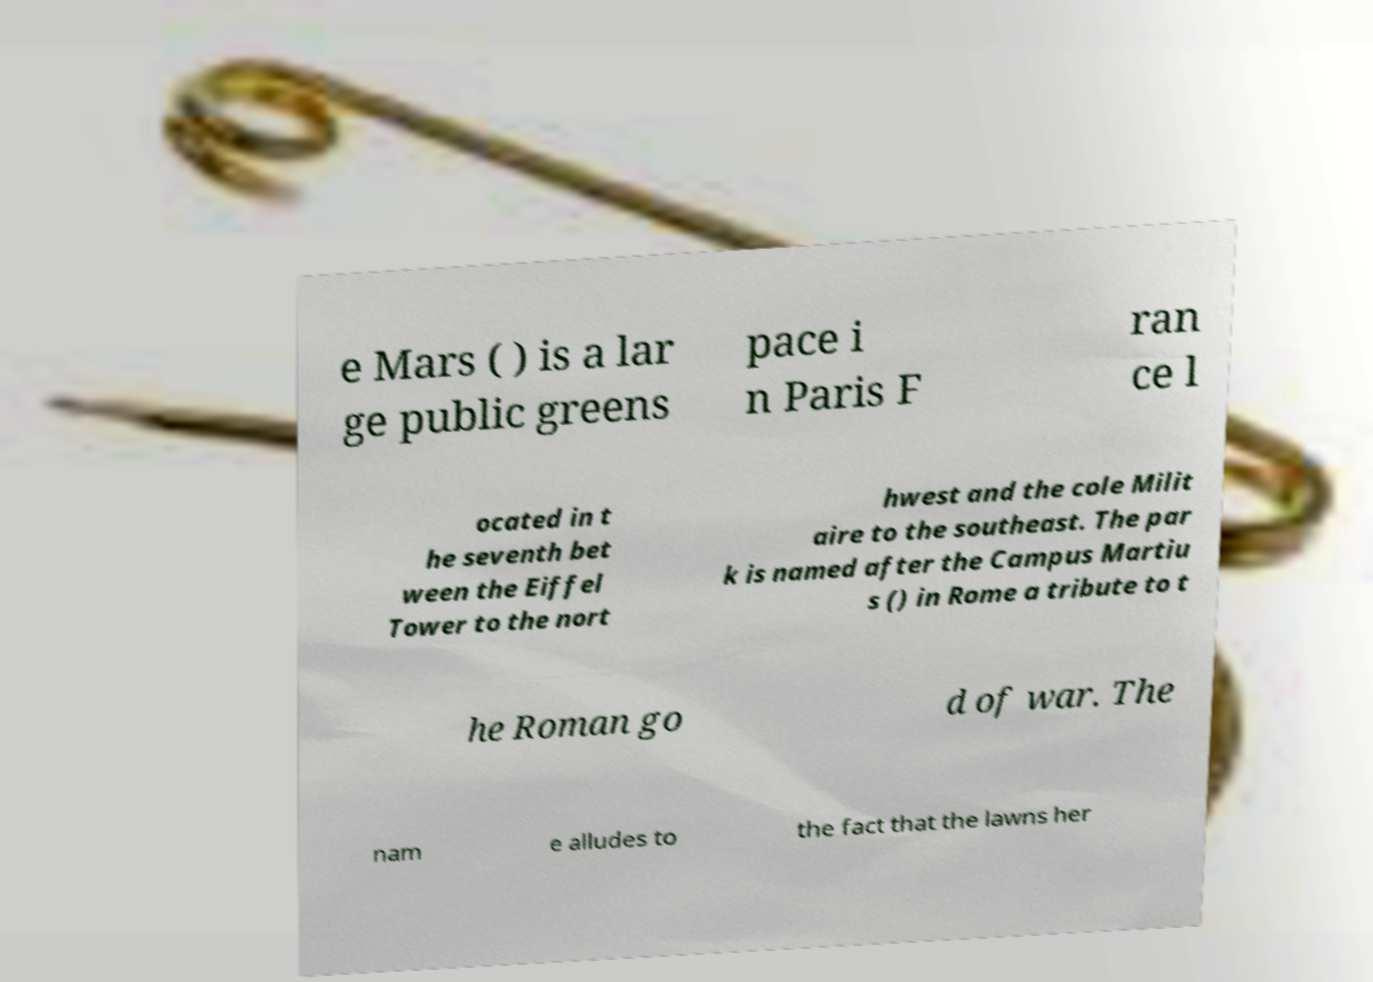Can you read and provide the text displayed in the image?This photo seems to have some interesting text. Can you extract and type it out for me? e Mars ( ) is a lar ge public greens pace i n Paris F ran ce l ocated in t he seventh bet ween the Eiffel Tower to the nort hwest and the cole Milit aire to the southeast. The par k is named after the Campus Martiu s () in Rome a tribute to t he Roman go d of war. The nam e alludes to the fact that the lawns her 